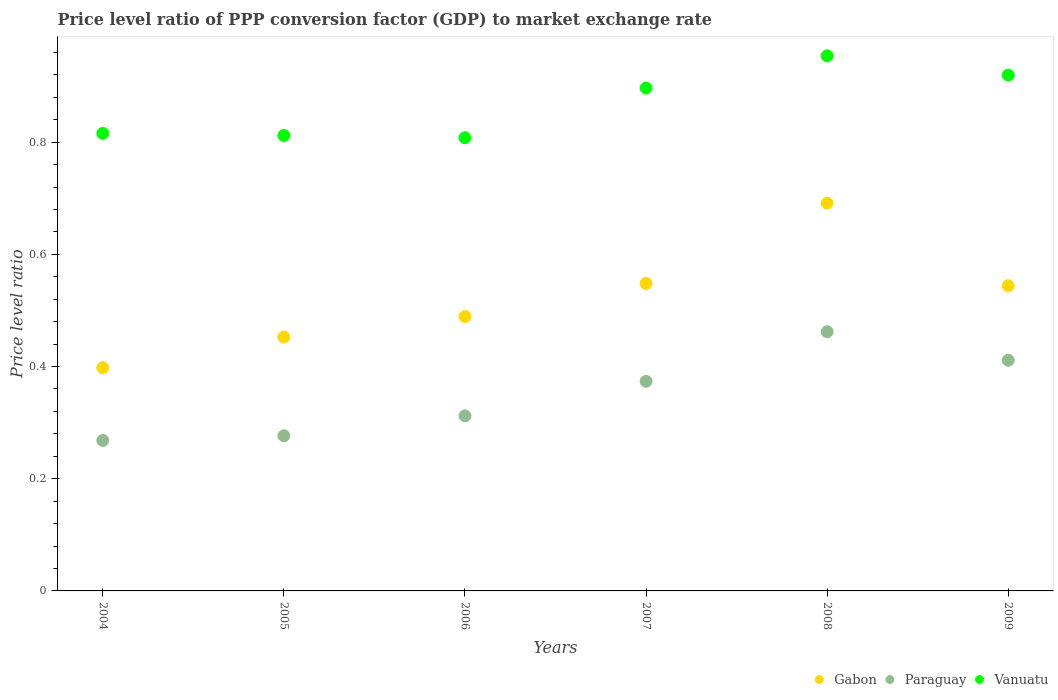How many different coloured dotlines are there?
Offer a terse response. 3. Is the number of dotlines equal to the number of legend labels?
Provide a short and direct response. Yes. What is the price level ratio in Gabon in 2006?
Make the answer very short. 0.49. Across all years, what is the maximum price level ratio in Gabon?
Offer a terse response. 0.69. Across all years, what is the minimum price level ratio in Vanuatu?
Your answer should be very brief. 0.81. In which year was the price level ratio in Gabon maximum?
Your answer should be very brief. 2008. What is the total price level ratio in Gabon in the graph?
Your answer should be compact. 3.12. What is the difference between the price level ratio in Vanuatu in 2004 and that in 2005?
Your answer should be compact. 0. What is the difference between the price level ratio in Vanuatu in 2004 and the price level ratio in Paraguay in 2005?
Offer a very short reply. 0.54. What is the average price level ratio in Vanuatu per year?
Give a very brief answer. 0.87. In the year 2006, what is the difference between the price level ratio in Gabon and price level ratio in Vanuatu?
Offer a terse response. -0.32. In how many years, is the price level ratio in Gabon greater than 0.7600000000000001?
Your answer should be very brief. 0. What is the ratio of the price level ratio in Paraguay in 2007 to that in 2009?
Your answer should be compact. 0.91. What is the difference between the highest and the second highest price level ratio in Paraguay?
Ensure brevity in your answer.  0.05. What is the difference between the highest and the lowest price level ratio in Paraguay?
Offer a very short reply. 0.19. In how many years, is the price level ratio in Paraguay greater than the average price level ratio in Paraguay taken over all years?
Provide a succinct answer. 3. Is the sum of the price level ratio in Vanuatu in 2004 and 2006 greater than the maximum price level ratio in Paraguay across all years?
Ensure brevity in your answer.  Yes. Does the price level ratio in Gabon monotonically increase over the years?
Provide a short and direct response. No. How many years are there in the graph?
Provide a short and direct response. 6. Does the graph contain any zero values?
Your response must be concise. No. How many legend labels are there?
Provide a short and direct response. 3. How are the legend labels stacked?
Ensure brevity in your answer.  Horizontal. What is the title of the graph?
Provide a succinct answer. Price level ratio of PPP conversion factor (GDP) to market exchange rate. What is the label or title of the X-axis?
Your answer should be compact. Years. What is the label or title of the Y-axis?
Offer a very short reply. Price level ratio. What is the Price level ratio of Gabon in 2004?
Your response must be concise. 0.4. What is the Price level ratio of Paraguay in 2004?
Provide a succinct answer. 0.27. What is the Price level ratio in Vanuatu in 2004?
Provide a succinct answer. 0.82. What is the Price level ratio of Gabon in 2005?
Give a very brief answer. 0.45. What is the Price level ratio of Paraguay in 2005?
Your answer should be very brief. 0.28. What is the Price level ratio in Vanuatu in 2005?
Your answer should be compact. 0.81. What is the Price level ratio of Gabon in 2006?
Your answer should be compact. 0.49. What is the Price level ratio of Paraguay in 2006?
Ensure brevity in your answer.  0.31. What is the Price level ratio of Vanuatu in 2006?
Keep it short and to the point. 0.81. What is the Price level ratio of Gabon in 2007?
Keep it short and to the point. 0.55. What is the Price level ratio in Paraguay in 2007?
Provide a succinct answer. 0.37. What is the Price level ratio of Vanuatu in 2007?
Ensure brevity in your answer.  0.9. What is the Price level ratio of Gabon in 2008?
Ensure brevity in your answer.  0.69. What is the Price level ratio in Paraguay in 2008?
Offer a very short reply. 0.46. What is the Price level ratio of Vanuatu in 2008?
Ensure brevity in your answer.  0.95. What is the Price level ratio of Gabon in 2009?
Keep it short and to the point. 0.54. What is the Price level ratio of Paraguay in 2009?
Give a very brief answer. 0.41. What is the Price level ratio of Vanuatu in 2009?
Ensure brevity in your answer.  0.92. Across all years, what is the maximum Price level ratio of Gabon?
Keep it short and to the point. 0.69. Across all years, what is the maximum Price level ratio of Paraguay?
Offer a very short reply. 0.46. Across all years, what is the maximum Price level ratio of Vanuatu?
Ensure brevity in your answer.  0.95. Across all years, what is the minimum Price level ratio in Gabon?
Give a very brief answer. 0.4. Across all years, what is the minimum Price level ratio of Paraguay?
Your response must be concise. 0.27. Across all years, what is the minimum Price level ratio of Vanuatu?
Make the answer very short. 0.81. What is the total Price level ratio in Gabon in the graph?
Provide a short and direct response. 3.12. What is the total Price level ratio of Paraguay in the graph?
Your answer should be very brief. 2.1. What is the total Price level ratio in Vanuatu in the graph?
Give a very brief answer. 5.21. What is the difference between the Price level ratio of Gabon in 2004 and that in 2005?
Your response must be concise. -0.05. What is the difference between the Price level ratio of Paraguay in 2004 and that in 2005?
Offer a very short reply. -0.01. What is the difference between the Price level ratio of Vanuatu in 2004 and that in 2005?
Give a very brief answer. 0. What is the difference between the Price level ratio in Gabon in 2004 and that in 2006?
Give a very brief answer. -0.09. What is the difference between the Price level ratio of Paraguay in 2004 and that in 2006?
Ensure brevity in your answer.  -0.04. What is the difference between the Price level ratio in Vanuatu in 2004 and that in 2006?
Provide a succinct answer. 0.01. What is the difference between the Price level ratio in Gabon in 2004 and that in 2007?
Provide a succinct answer. -0.15. What is the difference between the Price level ratio in Paraguay in 2004 and that in 2007?
Your answer should be very brief. -0.11. What is the difference between the Price level ratio in Vanuatu in 2004 and that in 2007?
Your response must be concise. -0.08. What is the difference between the Price level ratio in Gabon in 2004 and that in 2008?
Ensure brevity in your answer.  -0.29. What is the difference between the Price level ratio in Paraguay in 2004 and that in 2008?
Provide a succinct answer. -0.19. What is the difference between the Price level ratio of Vanuatu in 2004 and that in 2008?
Ensure brevity in your answer.  -0.14. What is the difference between the Price level ratio in Gabon in 2004 and that in 2009?
Offer a terse response. -0.15. What is the difference between the Price level ratio in Paraguay in 2004 and that in 2009?
Offer a very short reply. -0.14. What is the difference between the Price level ratio of Vanuatu in 2004 and that in 2009?
Your response must be concise. -0.1. What is the difference between the Price level ratio of Gabon in 2005 and that in 2006?
Provide a succinct answer. -0.04. What is the difference between the Price level ratio in Paraguay in 2005 and that in 2006?
Keep it short and to the point. -0.04. What is the difference between the Price level ratio in Vanuatu in 2005 and that in 2006?
Give a very brief answer. 0. What is the difference between the Price level ratio in Gabon in 2005 and that in 2007?
Your answer should be very brief. -0.1. What is the difference between the Price level ratio of Paraguay in 2005 and that in 2007?
Keep it short and to the point. -0.1. What is the difference between the Price level ratio in Vanuatu in 2005 and that in 2007?
Provide a short and direct response. -0.08. What is the difference between the Price level ratio in Gabon in 2005 and that in 2008?
Give a very brief answer. -0.24. What is the difference between the Price level ratio in Paraguay in 2005 and that in 2008?
Give a very brief answer. -0.19. What is the difference between the Price level ratio in Vanuatu in 2005 and that in 2008?
Offer a terse response. -0.14. What is the difference between the Price level ratio of Gabon in 2005 and that in 2009?
Offer a terse response. -0.09. What is the difference between the Price level ratio in Paraguay in 2005 and that in 2009?
Your answer should be very brief. -0.13. What is the difference between the Price level ratio in Vanuatu in 2005 and that in 2009?
Offer a very short reply. -0.11. What is the difference between the Price level ratio of Gabon in 2006 and that in 2007?
Your answer should be compact. -0.06. What is the difference between the Price level ratio of Paraguay in 2006 and that in 2007?
Give a very brief answer. -0.06. What is the difference between the Price level ratio of Vanuatu in 2006 and that in 2007?
Give a very brief answer. -0.09. What is the difference between the Price level ratio in Gabon in 2006 and that in 2008?
Provide a succinct answer. -0.2. What is the difference between the Price level ratio of Paraguay in 2006 and that in 2008?
Your response must be concise. -0.15. What is the difference between the Price level ratio in Vanuatu in 2006 and that in 2008?
Offer a terse response. -0.15. What is the difference between the Price level ratio of Gabon in 2006 and that in 2009?
Offer a terse response. -0.05. What is the difference between the Price level ratio in Paraguay in 2006 and that in 2009?
Offer a terse response. -0.1. What is the difference between the Price level ratio in Vanuatu in 2006 and that in 2009?
Your answer should be very brief. -0.11. What is the difference between the Price level ratio of Gabon in 2007 and that in 2008?
Make the answer very short. -0.14. What is the difference between the Price level ratio in Paraguay in 2007 and that in 2008?
Your response must be concise. -0.09. What is the difference between the Price level ratio of Vanuatu in 2007 and that in 2008?
Make the answer very short. -0.06. What is the difference between the Price level ratio of Gabon in 2007 and that in 2009?
Your response must be concise. 0. What is the difference between the Price level ratio of Paraguay in 2007 and that in 2009?
Provide a short and direct response. -0.04. What is the difference between the Price level ratio of Vanuatu in 2007 and that in 2009?
Ensure brevity in your answer.  -0.02. What is the difference between the Price level ratio in Gabon in 2008 and that in 2009?
Your answer should be compact. 0.15. What is the difference between the Price level ratio of Paraguay in 2008 and that in 2009?
Make the answer very short. 0.05. What is the difference between the Price level ratio in Vanuatu in 2008 and that in 2009?
Offer a terse response. 0.03. What is the difference between the Price level ratio of Gabon in 2004 and the Price level ratio of Paraguay in 2005?
Ensure brevity in your answer.  0.12. What is the difference between the Price level ratio in Gabon in 2004 and the Price level ratio in Vanuatu in 2005?
Your response must be concise. -0.41. What is the difference between the Price level ratio of Paraguay in 2004 and the Price level ratio of Vanuatu in 2005?
Offer a very short reply. -0.54. What is the difference between the Price level ratio of Gabon in 2004 and the Price level ratio of Paraguay in 2006?
Keep it short and to the point. 0.09. What is the difference between the Price level ratio of Gabon in 2004 and the Price level ratio of Vanuatu in 2006?
Keep it short and to the point. -0.41. What is the difference between the Price level ratio in Paraguay in 2004 and the Price level ratio in Vanuatu in 2006?
Your response must be concise. -0.54. What is the difference between the Price level ratio in Gabon in 2004 and the Price level ratio in Paraguay in 2007?
Offer a very short reply. 0.02. What is the difference between the Price level ratio of Gabon in 2004 and the Price level ratio of Vanuatu in 2007?
Your response must be concise. -0.5. What is the difference between the Price level ratio of Paraguay in 2004 and the Price level ratio of Vanuatu in 2007?
Your response must be concise. -0.63. What is the difference between the Price level ratio in Gabon in 2004 and the Price level ratio in Paraguay in 2008?
Your answer should be very brief. -0.06. What is the difference between the Price level ratio in Gabon in 2004 and the Price level ratio in Vanuatu in 2008?
Your answer should be compact. -0.56. What is the difference between the Price level ratio in Paraguay in 2004 and the Price level ratio in Vanuatu in 2008?
Offer a very short reply. -0.69. What is the difference between the Price level ratio of Gabon in 2004 and the Price level ratio of Paraguay in 2009?
Your answer should be very brief. -0.01. What is the difference between the Price level ratio of Gabon in 2004 and the Price level ratio of Vanuatu in 2009?
Keep it short and to the point. -0.52. What is the difference between the Price level ratio in Paraguay in 2004 and the Price level ratio in Vanuatu in 2009?
Your answer should be compact. -0.65. What is the difference between the Price level ratio in Gabon in 2005 and the Price level ratio in Paraguay in 2006?
Keep it short and to the point. 0.14. What is the difference between the Price level ratio of Gabon in 2005 and the Price level ratio of Vanuatu in 2006?
Your response must be concise. -0.36. What is the difference between the Price level ratio of Paraguay in 2005 and the Price level ratio of Vanuatu in 2006?
Ensure brevity in your answer.  -0.53. What is the difference between the Price level ratio of Gabon in 2005 and the Price level ratio of Paraguay in 2007?
Your answer should be very brief. 0.08. What is the difference between the Price level ratio of Gabon in 2005 and the Price level ratio of Vanuatu in 2007?
Your answer should be compact. -0.44. What is the difference between the Price level ratio in Paraguay in 2005 and the Price level ratio in Vanuatu in 2007?
Your answer should be very brief. -0.62. What is the difference between the Price level ratio of Gabon in 2005 and the Price level ratio of Paraguay in 2008?
Ensure brevity in your answer.  -0.01. What is the difference between the Price level ratio of Gabon in 2005 and the Price level ratio of Vanuatu in 2008?
Offer a terse response. -0.5. What is the difference between the Price level ratio of Paraguay in 2005 and the Price level ratio of Vanuatu in 2008?
Your answer should be very brief. -0.68. What is the difference between the Price level ratio of Gabon in 2005 and the Price level ratio of Paraguay in 2009?
Provide a short and direct response. 0.04. What is the difference between the Price level ratio of Gabon in 2005 and the Price level ratio of Vanuatu in 2009?
Provide a succinct answer. -0.47. What is the difference between the Price level ratio of Paraguay in 2005 and the Price level ratio of Vanuatu in 2009?
Make the answer very short. -0.64. What is the difference between the Price level ratio of Gabon in 2006 and the Price level ratio of Paraguay in 2007?
Your answer should be very brief. 0.12. What is the difference between the Price level ratio in Gabon in 2006 and the Price level ratio in Vanuatu in 2007?
Your answer should be very brief. -0.41. What is the difference between the Price level ratio in Paraguay in 2006 and the Price level ratio in Vanuatu in 2007?
Provide a short and direct response. -0.58. What is the difference between the Price level ratio in Gabon in 2006 and the Price level ratio in Paraguay in 2008?
Provide a succinct answer. 0.03. What is the difference between the Price level ratio of Gabon in 2006 and the Price level ratio of Vanuatu in 2008?
Your answer should be very brief. -0.46. What is the difference between the Price level ratio of Paraguay in 2006 and the Price level ratio of Vanuatu in 2008?
Keep it short and to the point. -0.64. What is the difference between the Price level ratio of Gabon in 2006 and the Price level ratio of Paraguay in 2009?
Make the answer very short. 0.08. What is the difference between the Price level ratio of Gabon in 2006 and the Price level ratio of Vanuatu in 2009?
Ensure brevity in your answer.  -0.43. What is the difference between the Price level ratio of Paraguay in 2006 and the Price level ratio of Vanuatu in 2009?
Provide a succinct answer. -0.61. What is the difference between the Price level ratio in Gabon in 2007 and the Price level ratio in Paraguay in 2008?
Ensure brevity in your answer.  0.09. What is the difference between the Price level ratio of Gabon in 2007 and the Price level ratio of Vanuatu in 2008?
Keep it short and to the point. -0.41. What is the difference between the Price level ratio of Paraguay in 2007 and the Price level ratio of Vanuatu in 2008?
Offer a terse response. -0.58. What is the difference between the Price level ratio in Gabon in 2007 and the Price level ratio in Paraguay in 2009?
Give a very brief answer. 0.14. What is the difference between the Price level ratio of Gabon in 2007 and the Price level ratio of Vanuatu in 2009?
Your response must be concise. -0.37. What is the difference between the Price level ratio of Paraguay in 2007 and the Price level ratio of Vanuatu in 2009?
Offer a terse response. -0.55. What is the difference between the Price level ratio in Gabon in 2008 and the Price level ratio in Paraguay in 2009?
Your answer should be very brief. 0.28. What is the difference between the Price level ratio in Gabon in 2008 and the Price level ratio in Vanuatu in 2009?
Provide a short and direct response. -0.23. What is the difference between the Price level ratio in Paraguay in 2008 and the Price level ratio in Vanuatu in 2009?
Your response must be concise. -0.46. What is the average Price level ratio of Gabon per year?
Offer a terse response. 0.52. What is the average Price level ratio in Paraguay per year?
Provide a short and direct response. 0.35. What is the average Price level ratio in Vanuatu per year?
Provide a succinct answer. 0.87. In the year 2004, what is the difference between the Price level ratio of Gabon and Price level ratio of Paraguay?
Keep it short and to the point. 0.13. In the year 2004, what is the difference between the Price level ratio of Gabon and Price level ratio of Vanuatu?
Your response must be concise. -0.42. In the year 2004, what is the difference between the Price level ratio in Paraguay and Price level ratio in Vanuatu?
Give a very brief answer. -0.55. In the year 2005, what is the difference between the Price level ratio in Gabon and Price level ratio in Paraguay?
Make the answer very short. 0.18. In the year 2005, what is the difference between the Price level ratio of Gabon and Price level ratio of Vanuatu?
Provide a short and direct response. -0.36. In the year 2005, what is the difference between the Price level ratio of Paraguay and Price level ratio of Vanuatu?
Make the answer very short. -0.54. In the year 2006, what is the difference between the Price level ratio in Gabon and Price level ratio in Paraguay?
Your response must be concise. 0.18. In the year 2006, what is the difference between the Price level ratio in Gabon and Price level ratio in Vanuatu?
Provide a succinct answer. -0.32. In the year 2006, what is the difference between the Price level ratio of Paraguay and Price level ratio of Vanuatu?
Give a very brief answer. -0.5. In the year 2007, what is the difference between the Price level ratio of Gabon and Price level ratio of Paraguay?
Give a very brief answer. 0.17. In the year 2007, what is the difference between the Price level ratio in Gabon and Price level ratio in Vanuatu?
Offer a very short reply. -0.35. In the year 2007, what is the difference between the Price level ratio in Paraguay and Price level ratio in Vanuatu?
Provide a succinct answer. -0.52. In the year 2008, what is the difference between the Price level ratio in Gabon and Price level ratio in Paraguay?
Offer a terse response. 0.23. In the year 2008, what is the difference between the Price level ratio in Gabon and Price level ratio in Vanuatu?
Your answer should be compact. -0.26. In the year 2008, what is the difference between the Price level ratio of Paraguay and Price level ratio of Vanuatu?
Your answer should be very brief. -0.49. In the year 2009, what is the difference between the Price level ratio in Gabon and Price level ratio in Paraguay?
Provide a short and direct response. 0.13. In the year 2009, what is the difference between the Price level ratio in Gabon and Price level ratio in Vanuatu?
Keep it short and to the point. -0.38. In the year 2009, what is the difference between the Price level ratio of Paraguay and Price level ratio of Vanuatu?
Offer a terse response. -0.51. What is the ratio of the Price level ratio of Gabon in 2004 to that in 2005?
Your answer should be very brief. 0.88. What is the ratio of the Price level ratio of Paraguay in 2004 to that in 2005?
Provide a succinct answer. 0.97. What is the ratio of the Price level ratio of Vanuatu in 2004 to that in 2005?
Offer a very short reply. 1. What is the ratio of the Price level ratio in Gabon in 2004 to that in 2006?
Offer a very short reply. 0.81. What is the ratio of the Price level ratio in Paraguay in 2004 to that in 2006?
Your answer should be very brief. 0.86. What is the ratio of the Price level ratio of Vanuatu in 2004 to that in 2006?
Your answer should be very brief. 1.01. What is the ratio of the Price level ratio of Gabon in 2004 to that in 2007?
Your response must be concise. 0.73. What is the ratio of the Price level ratio in Paraguay in 2004 to that in 2007?
Provide a short and direct response. 0.72. What is the ratio of the Price level ratio in Vanuatu in 2004 to that in 2007?
Offer a very short reply. 0.91. What is the ratio of the Price level ratio in Gabon in 2004 to that in 2008?
Your answer should be very brief. 0.58. What is the ratio of the Price level ratio in Paraguay in 2004 to that in 2008?
Your answer should be compact. 0.58. What is the ratio of the Price level ratio in Vanuatu in 2004 to that in 2008?
Provide a succinct answer. 0.85. What is the ratio of the Price level ratio of Gabon in 2004 to that in 2009?
Ensure brevity in your answer.  0.73. What is the ratio of the Price level ratio in Paraguay in 2004 to that in 2009?
Ensure brevity in your answer.  0.65. What is the ratio of the Price level ratio of Vanuatu in 2004 to that in 2009?
Offer a terse response. 0.89. What is the ratio of the Price level ratio of Gabon in 2005 to that in 2006?
Your response must be concise. 0.93. What is the ratio of the Price level ratio of Paraguay in 2005 to that in 2006?
Your answer should be compact. 0.89. What is the ratio of the Price level ratio of Vanuatu in 2005 to that in 2006?
Your response must be concise. 1. What is the ratio of the Price level ratio in Gabon in 2005 to that in 2007?
Provide a succinct answer. 0.83. What is the ratio of the Price level ratio of Paraguay in 2005 to that in 2007?
Offer a terse response. 0.74. What is the ratio of the Price level ratio in Vanuatu in 2005 to that in 2007?
Your answer should be very brief. 0.91. What is the ratio of the Price level ratio in Gabon in 2005 to that in 2008?
Ensure brevity in your answer.  0.65. What is the ratio of the Price level ratio in Paraguay in 2005 to that in 2008?
Ensure brevity in your answer.  0.6. What is the ratio of the Price level ratio in Vanuatu in 2005 to that in 2008?
Keep it short and to the point. 0.85. What is the ratio of the Price level ratio in Gabon in 2005 to that in 2009?
Provide a succinct answer. 0.83. What is the ratio of the Price level ratio of Paraguay in 2005 to that in 2009?
Give a very brief answer. 0.67. What is the ratio of the Price level ratio in Vanuatu in 2005 to that in 2009?
Ensure brevity in your answer.  0.88. What is the ratio of the Price level ratio of Gabon in 2006 to that in 2007?
Offer a very short reply. 0.89. What is the ratio of the Price level ratio in Paraguay in 2006 to that in 2007?
Provide a succinct answer. 0.84. What is the ratio of the Price level ratio of Vanuatu in 2006 to that in 2007?
Provide a succinct answer. 0.9. What is the ratio of the Price level ratio of Gabon in 2006 to that in 2008?
Offer a terse response. 0.71. What is the ratio of the Price level ratio of Paraguay in 2006 to that in 2008?
Your answer should be very brief. 0.68. What is the ratio of the Price level ratio of Vanuatu in 2006 to that in 2008?
Your answer should be compact. 0.85. What is the ratio of the Price level ratio in Gabon in 2006 to that in 2009?
Your response must be concise. 0.9. What is the ratio of the Price level ratio in Paraguay in 2006 to that in 2009?
Offer a very short reply. 0.76. What is the ratio of the Price level ratio of Vanuatu in 2006 to that in 2009?
Offer a very short reply. 0.88. What is the ratio of the Price level ratio in Gabon in 2007 to that in 2008?
Your answer should be compact. 0.79. What is the ratio of the Price level ratio in Paraguay in 2007 to that in 2008?
Provide a succinct answer. 0.81. What is the ratio of the Price level ratio in Vanuatu in 2007 to that in 2008?
Provide a short and direct response. 0.94. What is the ratio of the Price level ratio in Gabon in 2007 to that in 2009?
Your answer should be compact. 1.01. What is the ratio of the Price level ratio in Paraguay in 2007 to that in 2009?
Provide a succinct answer. 0.91. What is the ratio of the Price level ratio in Vanuatu in 2007 to that in 2009?
Keep it short and to the point. 0.97. What is the ratio of the Price level ratio in Gabon in 2008 to that in 2009?
Keep it short and to the point. 1.27. What is the ratio of the Price level ratio in Paraguay in 2008 to that in 2009?
Provide a short and direct response. 1.12. What is the ratio of the Price level ratio of Vanuatu in 2008 to that in 2009?
Keep it short and to the point. 1.04. What is the difference between the highest and the second highest Price level ratio in Gabon?
Make the answer very short. 0.14. What is the difference between the highest and the second highest Price level ratio in Paraguay?
Offer a terse response. 0.05. What is the difference between the highest and the second highest Price level ratio in Vanuatu?
Make the answer very short. 0.03. What is the difference between the highest and the lowest Price level ratio in Gabon?
Your answer should be compact. 0.29. What is the difference between the highest and the lowest Price level ratio of Paraguay?
Provide a short and direct response. 0.19. What is the difference between the highest and the lowest Price level ratio in Vanuatu?
Provide a short and direct response. 0.15. 